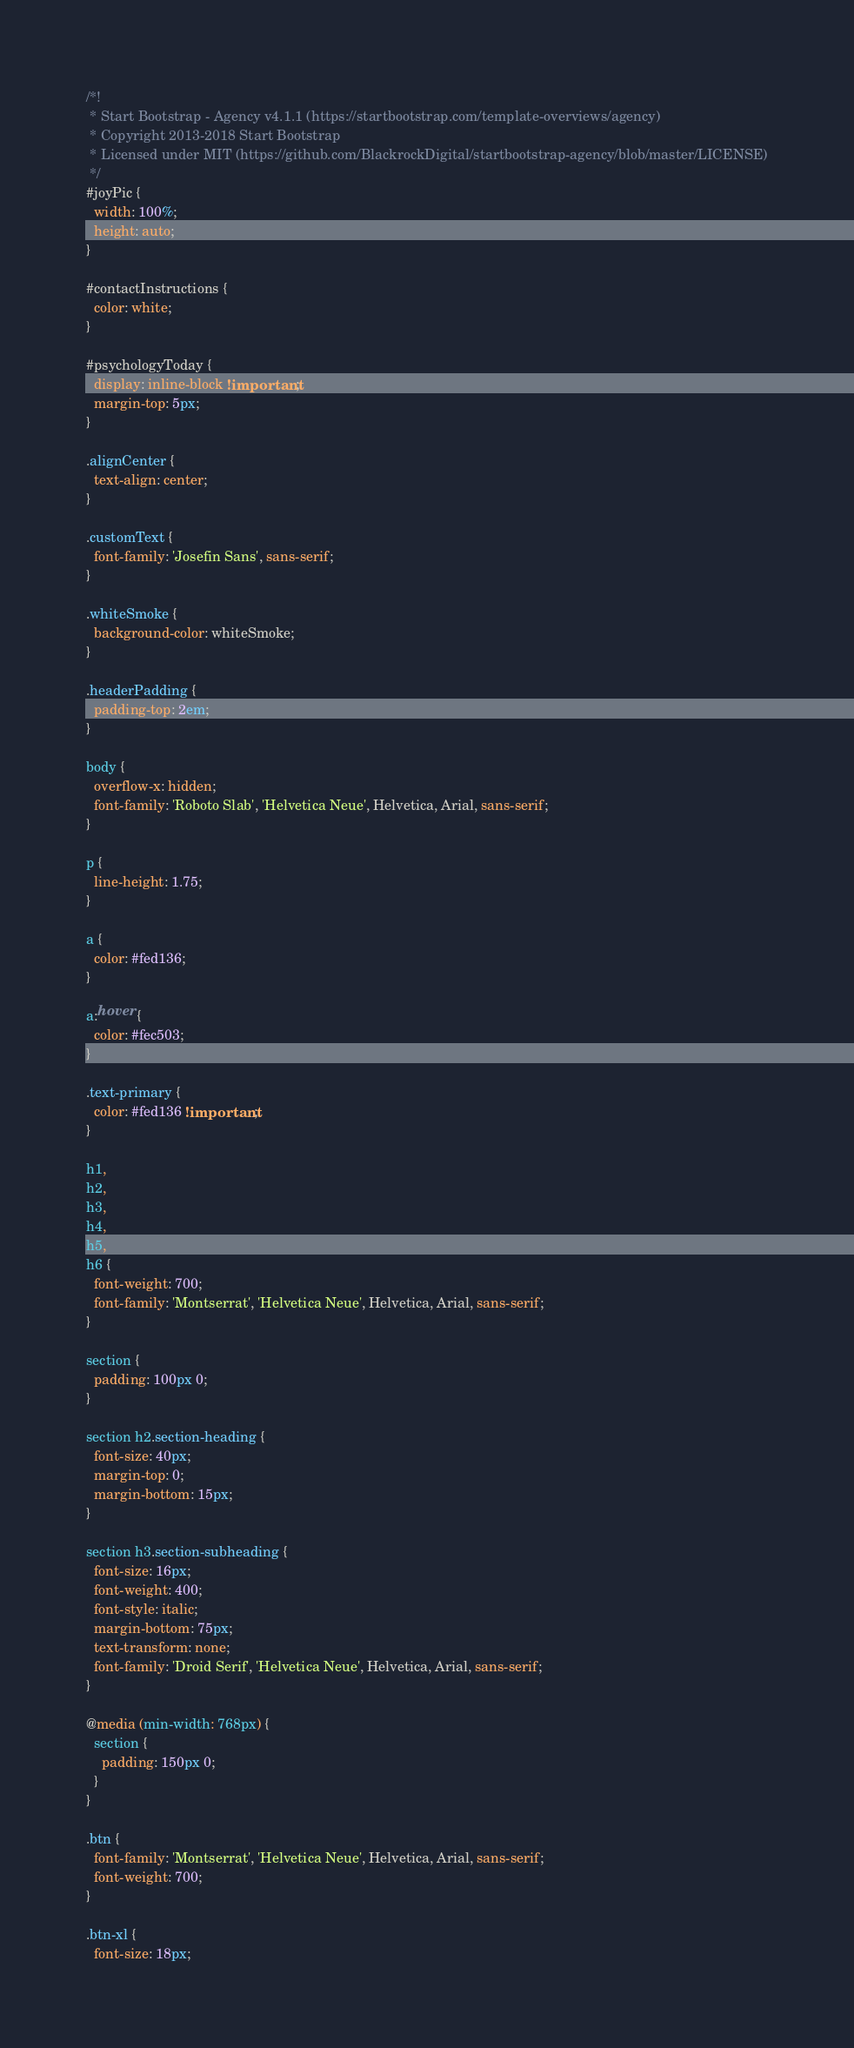<code> <loc_0><loc_0><loc_500><loc_500><_CSS_>/*!
 * Start Bootstrap - Agency v4.1.1 (https://startbootstrap.com/template-overviews/agency)
 * Copyright 2013-2018 Start Bootstrap
 * Licensed under MIT (https://github.com/BlackrockDigital/startbootstrap-agency/blob/master/LICENSE)
 */
#joyPic {
  width: 100%;
  height: auto;
}

#contactInstructions {
  color: white;
}

#psychologyToday {
  display: inline-block !important;
  margin-top: 5px;
}

.alignCenter {
  text-align: center;
}

.customText {
  font-family: 'Josefin Sans', sans-serif;
}

.whiteSmoke {
  background-color: whiteSmoke;
}

.headerPadding {
  padding-top: 2em;
}

body {
  overflow-x: hidden;
  font-family: 'Roboto Slab', 'Helvetica Neue', Helvetica, Arial, sans-serif;
}

p {
  line-height: 1.75;
}

a {
  color: #fed136;
}

a:hover {
  color: #fec503;
}

.text-primary {
  color: #fed136 !important;
}

h1,
h2,
h3,
h4,
h5,
h6 {
  font-weight: 700;
  font-family: 'Montserrat', 'Helvetica Neue', Helvetica, Arial, sans-serif;
}

section {
  padding: 100px 0;
}

section h2.section-heading {
  font-size: 40px;
  margin-top: 0;
  margin-bottom: 15px;
}

section h3.section-subheading {
  font-size: 16px;
  font-weight: 400;
  font-style: italic;
  margin-bottom: 75px;
  text-transform: none;
  font-family: 'Droid Serif', 'Helvetica Neue', Helvetica, Arial, sans-serif;
}

@media (min-width: 768px) {
  section {
    padding: 150px 0;
  }
}

.btn {
  font-family: 'Montserrat', 'Helvetica Neue', Helvetica, Arial, sans-serif;
  font-weight: 700;
}

.btn-xl {
  font-size: 18px;</code> 